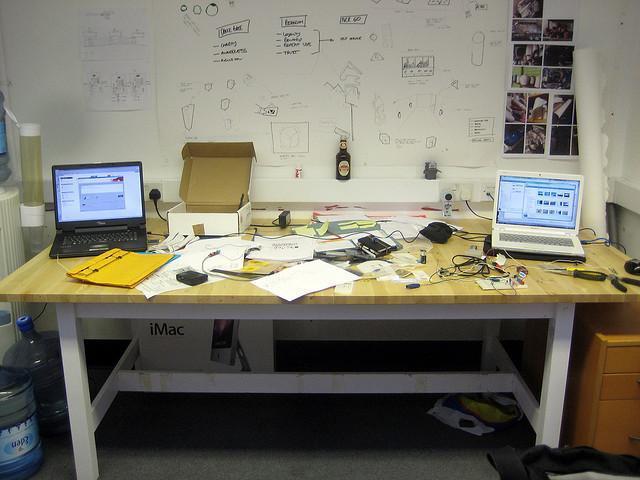How many computers?
Give a very brief answer. 2. How many laptops are on the table?
Give a very brief answer. 2. How many laptops are there?
Give a very brief answer. 2. 